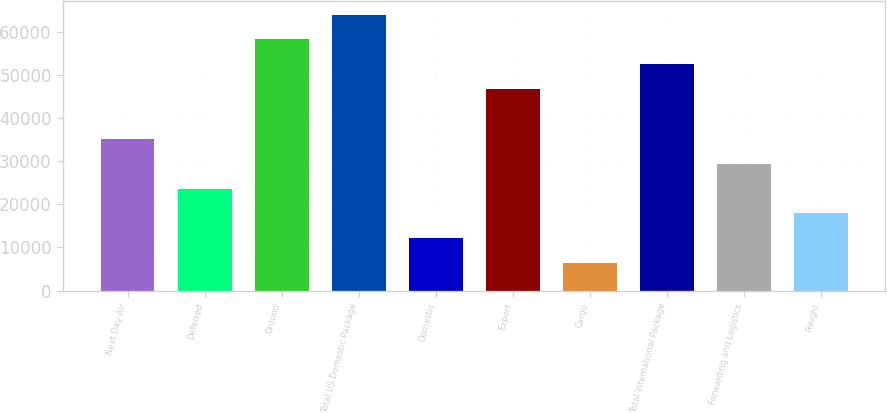<chart> <loc_0><loc_0><loc_500><loc_500><bar_chart><fcel>Next Day Air<fcel>Deferred<fcel>Ground<fcel>Total US Domestic Package<fcel>Domestic<fcel>Export<fcel>Cargo<fcel>Total International Package<fcel>Forwarding and Logistics<fcel>Freight<nl><fcel>35174<fcel>23645<fcel>58232<fcel>63996.5<fcel>12116<fcel>46703<fcel>6351.5<fcel>52467.5<fcel>29409.5<fcel>17880.5<nl></chart> 